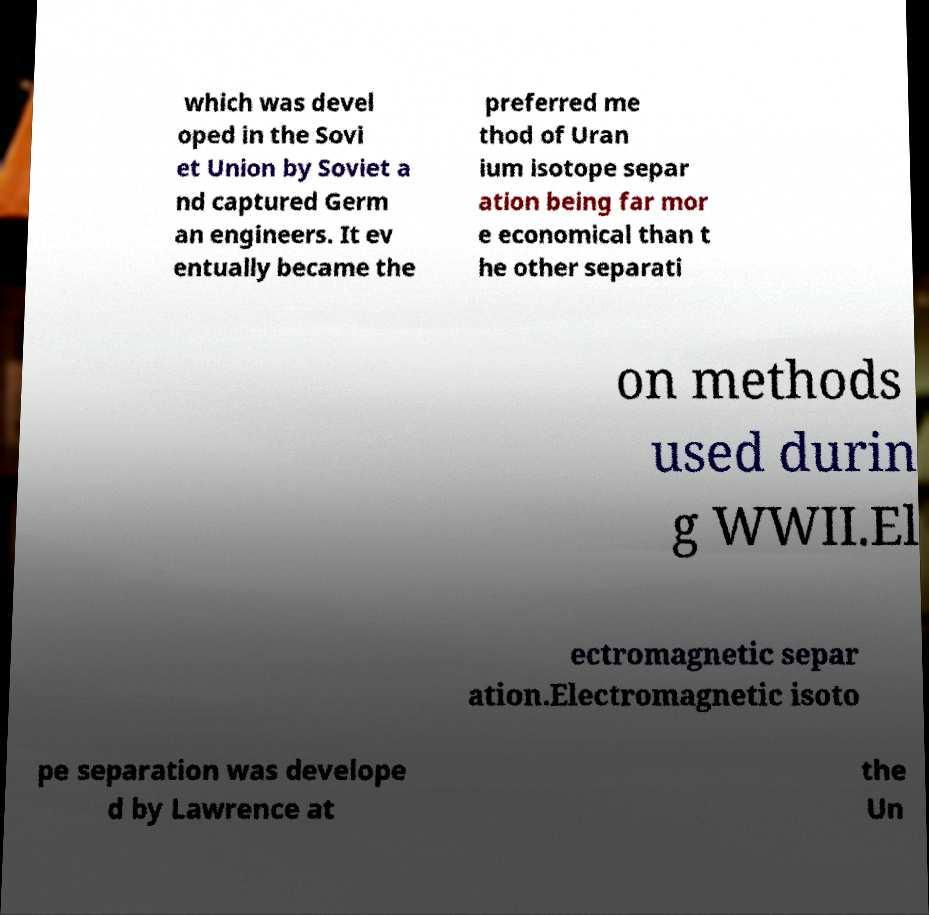For documentation purposes, I need the text within this image transcribed. Could you provide that? which was devel oped in the Sovi et Union by Soviet a nd captured Germ an engineers. It ev entually became the preferred me thod of Uran ium isotope separ ation being far mor e economical than t he other separati on methods used durin g WWII.El ectromagnetic separ ation.Electromagnetic isoto pe separation was develope d by Lawrence at the Un 